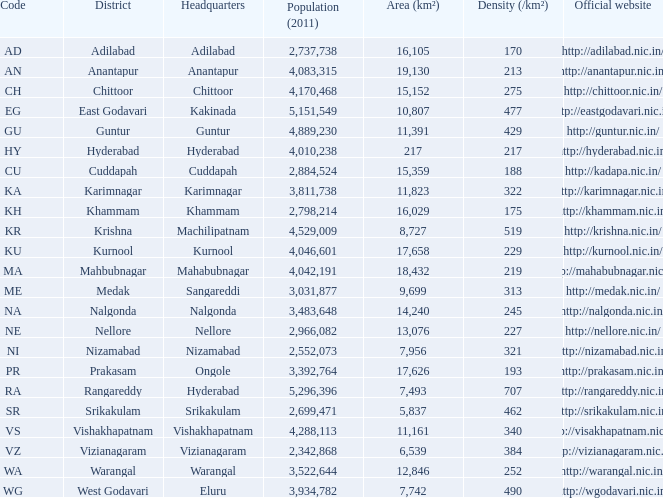What is the sum of the area values for districts having density over 462 and websites of http://krishna.nic.in/? 8727.0. 